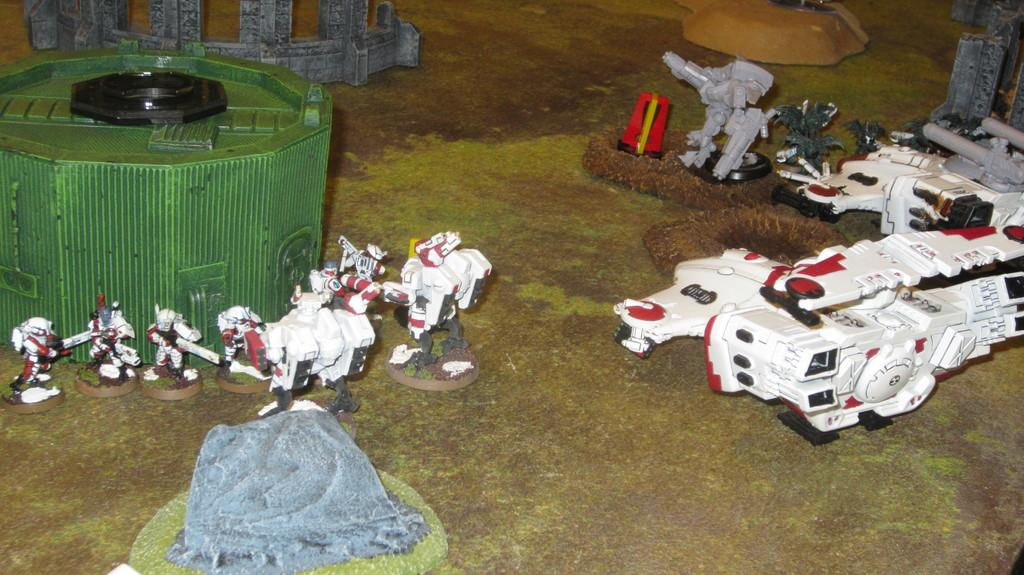What can be seen in the foreground of the picture? There are toys, a box, and other objects in the foreground of the picture. What type of surface is visible in the picture? There is grass visible in the picture. What color is the match that is being blown out in the picture? There is no match or blowing out of a match present in the picture. 